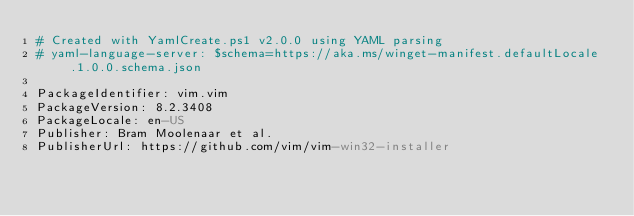Convert code to text. <code><loc_0><loc_0><loc_500><loc_500><_YAML_># Created with YamlCreate.ps1 v2.0.0 using YAML parsing
# yaml-language-server: $schema=https://aka.ms/winget-manifest.defaultLocale.1.0.0.schema.json

PackageIdentifier: vim.vim
PackageVersion: 8.2.3408
PackageLocale: en-US
Publisher: Bram Moolenaar et al.
PublisherUrl: https://github.com/vim/vim-win32-installer</code> 